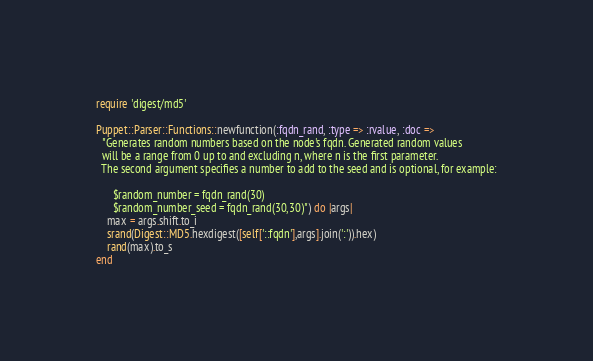Convert code to text. <code><loc_0><loc_0><loc_500><loc_500><_Ruby_>require 'digest/md5'

Puppet::Parser::Functions::newfunction(:fqdn_rand, :type => :rvalue, :doc =>
  "Generates random numbers based on the node's fqdn. Generated random values
  will be a range from 0 up to and excluding n, where n is the first parameter.
  The second argument specifies a number to add to the seed and is optional, for example:

      $random_number = fqdn_rand(30)
      $random_number_seed = fqdn_rand(30,30)") do |args|
    max = args.shift.to_i
    srand(Digest::MD5.hexdigest([self['::fqdn'],args].join(':')).hex)
    rand(max).to_s
end
</code> 